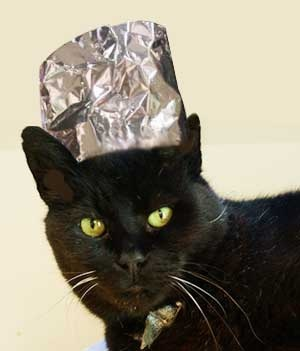Describe the objects in this image and their specific colors. I can see a cat in beige, black, gray, and darkgreen tones in this image. 